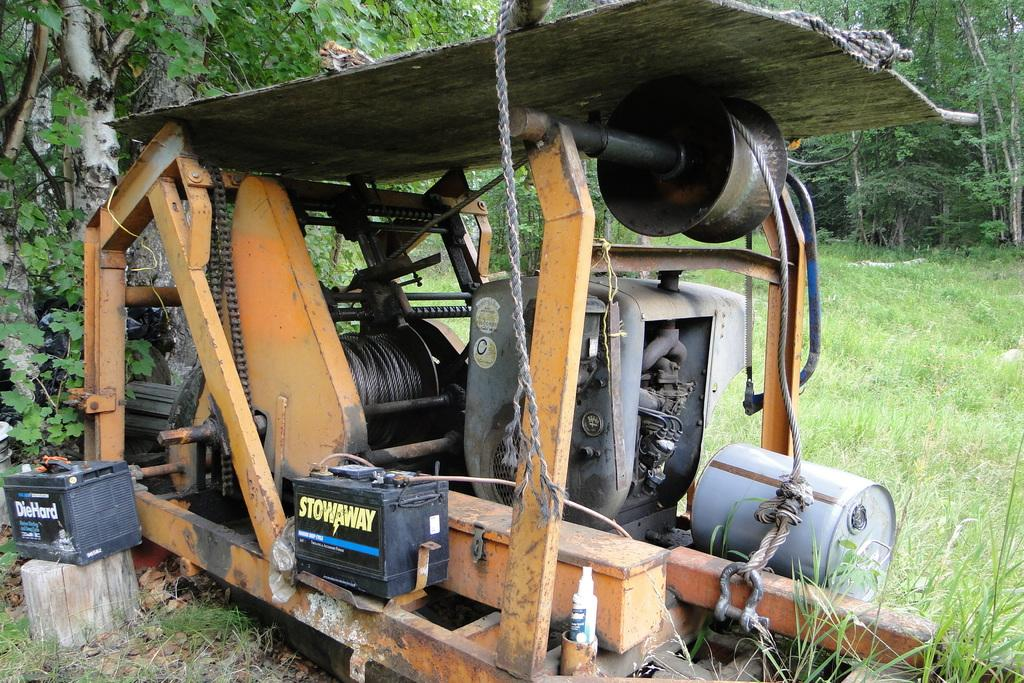What is the primary vegetation covering the land in the image? The land in the image is covered with grass. What type of object can be seen in the image? There is a machine in the image. What can be seen in the distance in the image? There are trees in the background of the image. What type of loaf is being used to cover the machine in the image? There is no loaf present in the image, and the machine is not being covered by any object. 